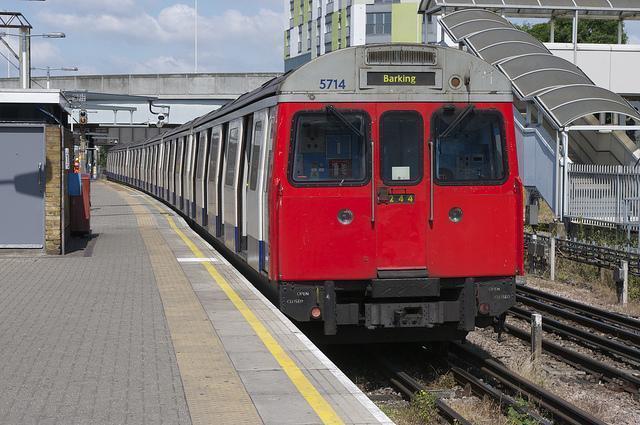How many lights are lit on the front of the train?
Give a very brief answer. 0. 